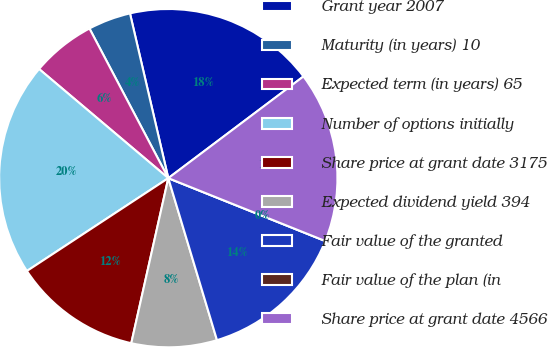<chart> <loc_0><loc_0><loc_500><loc_500><pie_chart><fcel>Grant year 2007<fcel>Maturity (in years) 10<fcel>Expected term (in years) 65<fcel>Number of options initially<fcel>Share price at grant date 3175<fcel>Expected dividend yield 394<fcel>Fair value of the granted<fcel>Fair value of the plan (in<fcel>Share price at grant date 4566<nl><fcel>18.37%<fcel>4.08%<fcel>6.12%<fcel>20.41%<fcel>12.24%<fcel>8.16%<fcel>14.29%<fcel>0.0%<fcel>16.33%<nl></chart> 